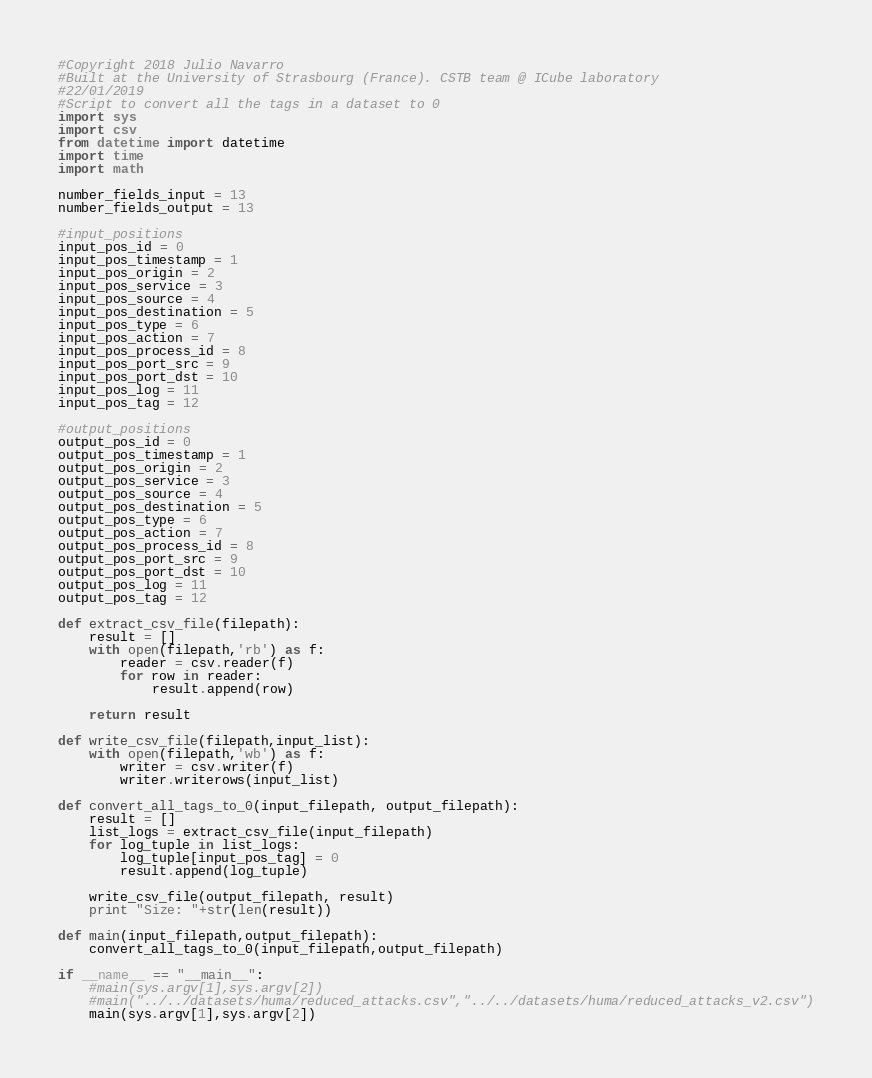<code> <loc_0><loc_0><loc_500><loc_500><_Python_>#Copyright 2018 Julio Navarro
#Built at the University of Strasbourg (France). CSTB team @ ICube laboratory
#22/01/2019
#Script to convert all the tags in a dataset to 0
import sys
import csv
from datetime import datetime
import time
import math

number_fields_input = 13
number_fields_output = 13

#input_positions
input_pos_id = 0
input_pos_timestamp = 1
input_pos_origin = 2
input_pos_service = 3
input_pos_source = 4
input_pos_destination = 5
input_pos_type = 6
input_pos_action = 7
input_pos_process_id = 8
input_pos_port_src = 9
input_pos_port_dst = 10
input_pos_log = 11
input_pos_tag = 12

#output_positions
output_pos_id = 0
output_pos_timestamp = 1
output_pos_origin = 2
output_pos_service = 3
output_pos_source = 4
output_pos_destination = 5
output_pos_type = 6
output_pos_action = 7
output_pos_process_id = 8
output_pos_port_src = 9
output_pos_port_dst = 10
output_pos_log = 11
output_pos_tag = 12

def extract_csv_file(filepath):
    result = []
    with open(filepath,'rb') as f:
        reader = csv.reader(f)
        for row in reader:
            result.append(row)

    return result

def write_csv_file(filepath,input_list):
    with open(filepath,'wb') as f:
        writer = csv.writer(f)
        writer.writerows(input_list)

def convert_all_tags_to_0(input_filepath, output_filepath):
    result = []
    list_logs = extract_csv_file(input_filepath)
    for log_tuple in list_logs:
        log_tuple[input_pos_tag] = 0
        result.append(log_tuple)

    write_csv_file(output_filepath, result)
    print "Size: "+str(len(result))

def main(input_filepath,output_filepath):
    convert_all_tags_to_0(input_filepath,output_filepath)

if __name__ == "__main__":
    #main(sys.argv[1],sys.argv[2])
    #main("../../datasets/huma/reduced_attacks.csv","../../datasets/huma/reduced_attacks_v2.csv")
    main(sys.argv[1],sys.argv[2])
</code> 